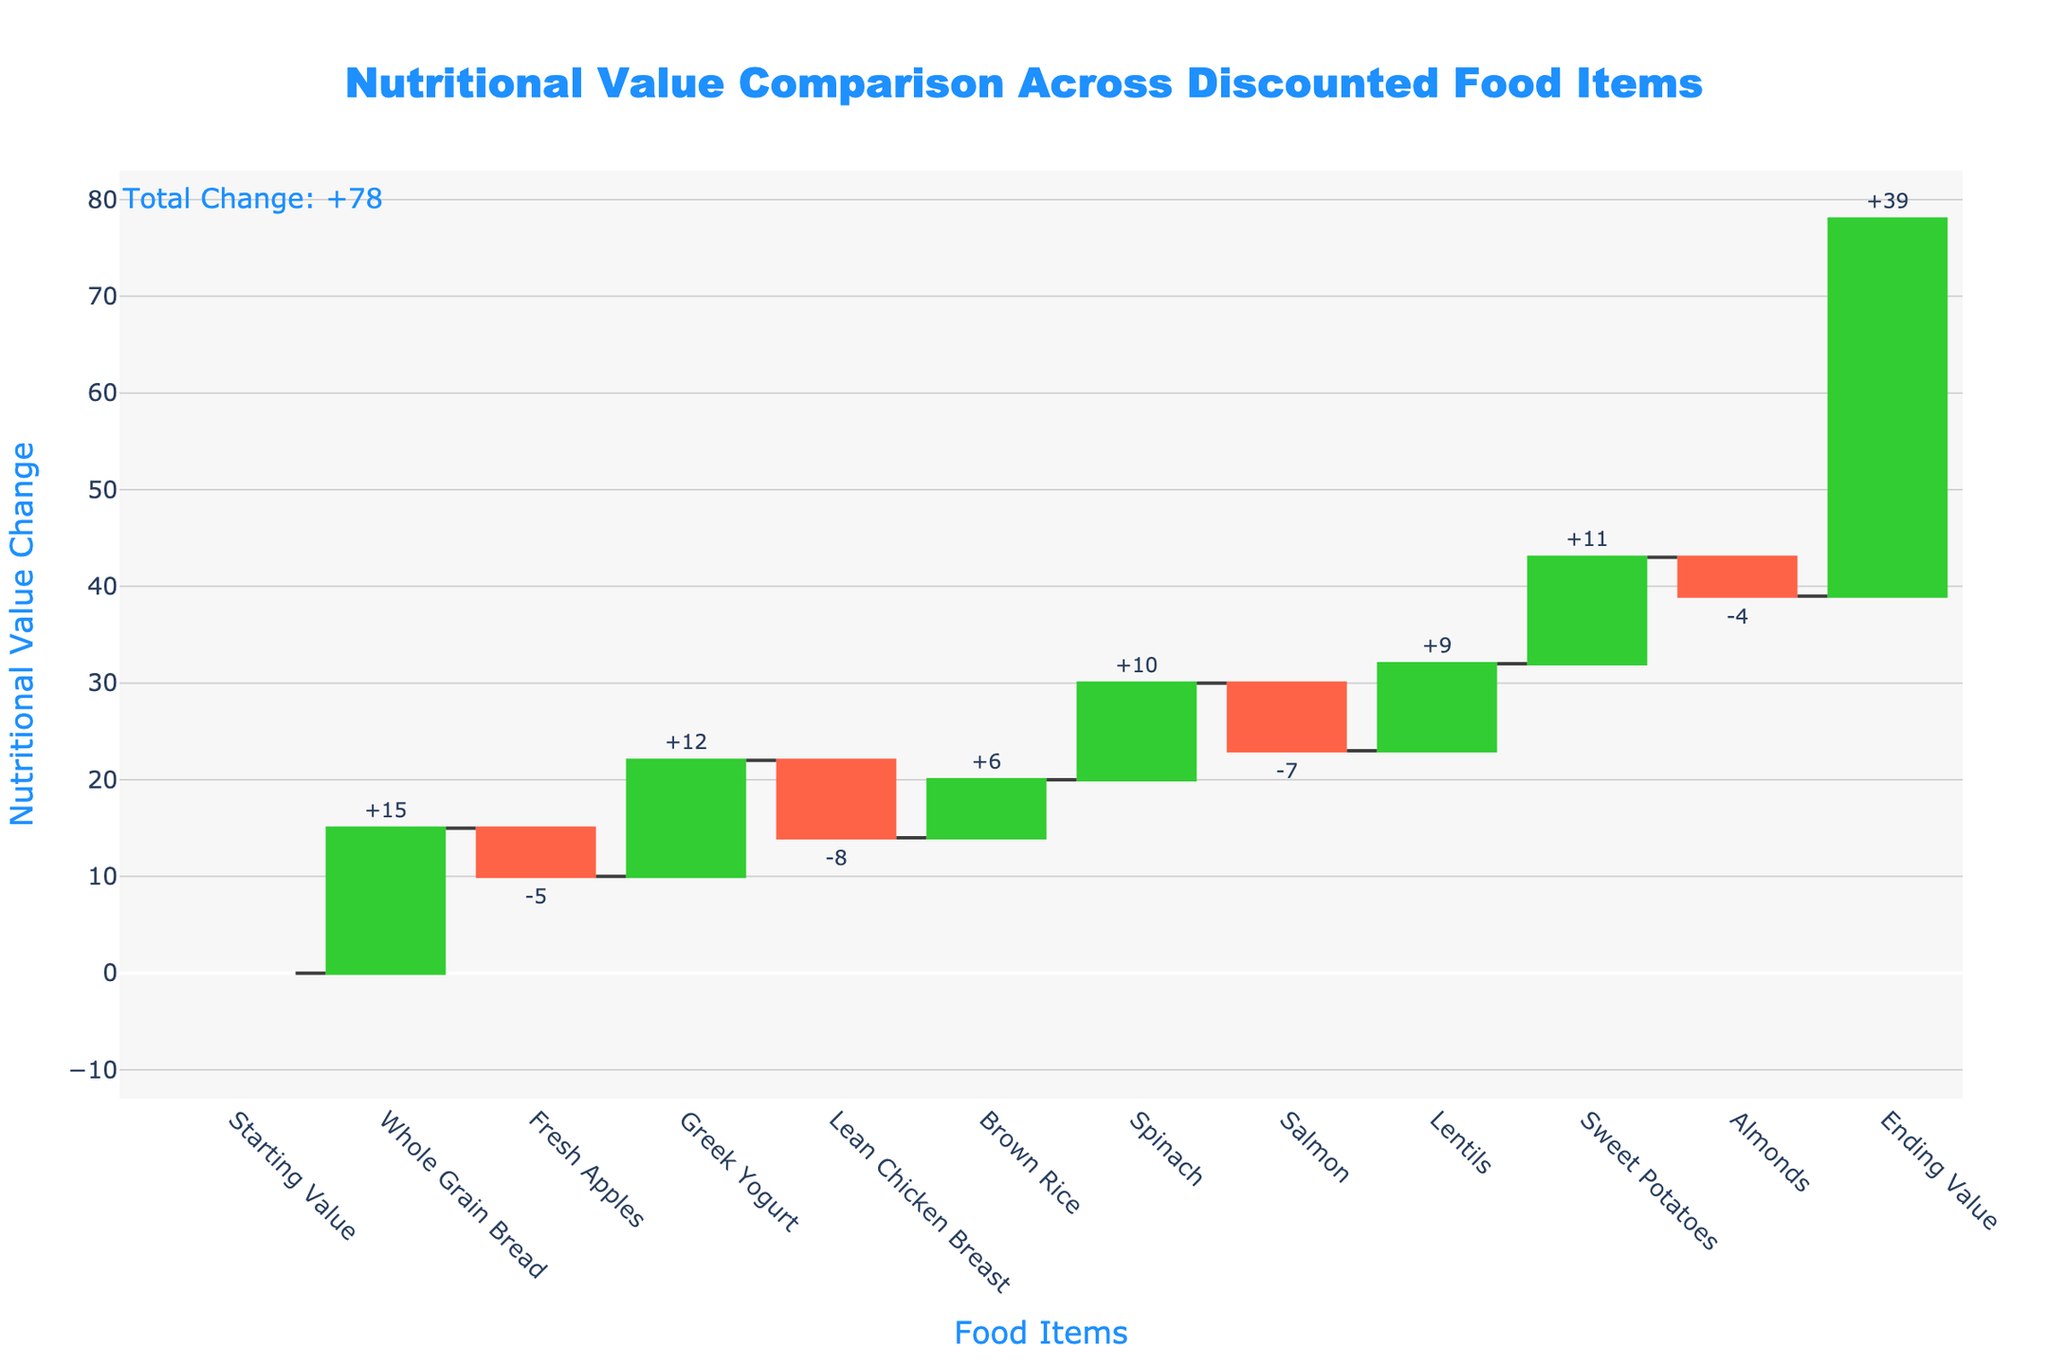What is the title of the chart? The title of a chart is usually displayed at the top of the figure. In this case, the title would be above the chart itself.
Answer: Nutritional Value Comparison Across Discounted Food Items How many food items showed an increase in nutritional value? To determine this, we look for the bars colored in green, representing an increase in nutritional value. Count the number of such bars.
Answer: 6 Which single food item had the highest increase in nutritional value? To find the food item with the highest increase, look for the tallest green bar. Examine the labels to identify the corresponding food item.
Answer: Whole Grain Bread What is the total change in nutritional value at the end of the chart? The total change is usually annotated on waterfall charts. It is the sum of all individual changes from start to end. Look for the annotation near the end of the chart.
Answer: 39 Which two food items have the closest change in nutritional value? To identify the food items with the closest change, compare the heights of the bars and find the bars with minimal difference in height. Examine the corresponding labels for these bars.
Answer: Brown Rice and Lentils By how much does Greek Yogurt increase the nutritional value? Locate the bar for Greek Yogurt, annotated with the change value, and note the number. It will be a positive value if it increases the nutritional value.
Answer: 12 What is the cumulative nutritional value after adding Spinach? Calculate the cumulative value by summing up the changes from the starting value through Spinach. Starting value + Whole Grain Bread + Fresh Apples + Greek Yogurt + Lean Chicken Breast + Brown Rice + Spinach.
Answer: 30 Which food item contributes the least to the nutritional value increase? By identifying the smallest green bar, you can determine which food item has the least positive contribution.
Answer: Almonds What is the difference in nutritional value change between Salmon and Sweet Potatoes? Find the change values for both Salmon and Sweet Potatoes. Then, calculate the difference between these values.
Answer: 18 What is the average change in nutritional value across all food items? Sum up all the changes in nutritional value and divide by the number of food items to find the average. (-5 + 15 + 12 - 8 + 6 + 10 - 7 + 9 + 11 - 4)/10.
Answer: 3.9 